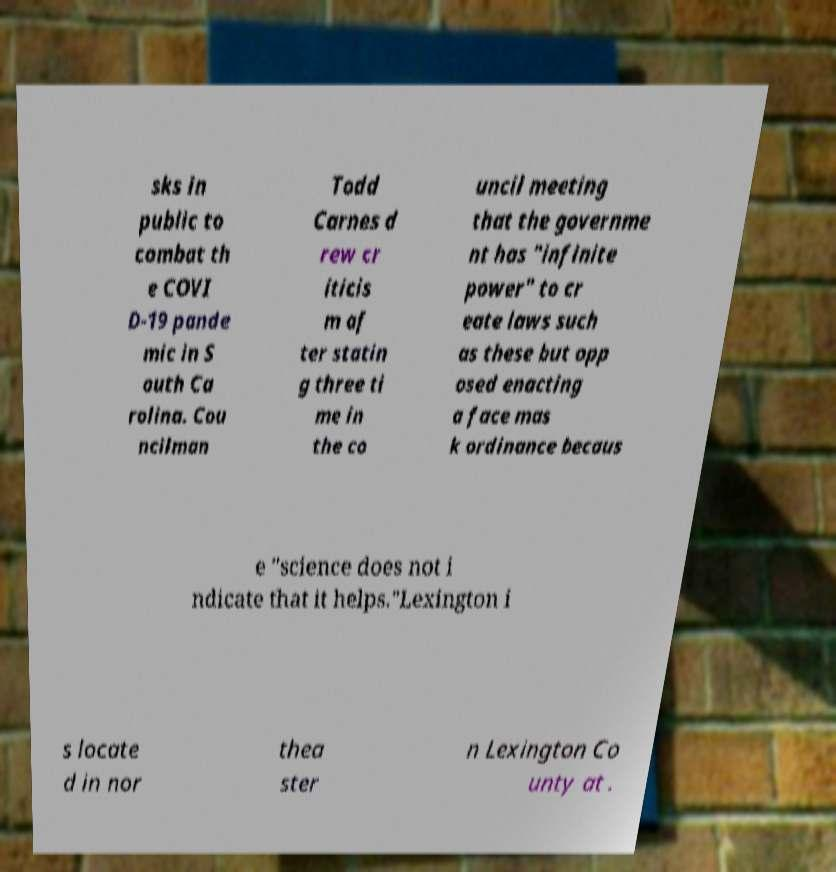Please read and relay the text visible in this image. What does it say? sks in public to combat th e COVI D-19 pande mic in S outh Ca rolina. Cou ncilman Todd Carnes d rew cr iticis m af ter statin g three ti me in the co uncil meeting that the governme nt has "infinite power" to cr eate laws such as these but opp osed enacting a face mas k ordinance becaus e "science does not i ndicate that it helps."Lexington i s locate d in nor thea ster n Lexington Co unty at . 